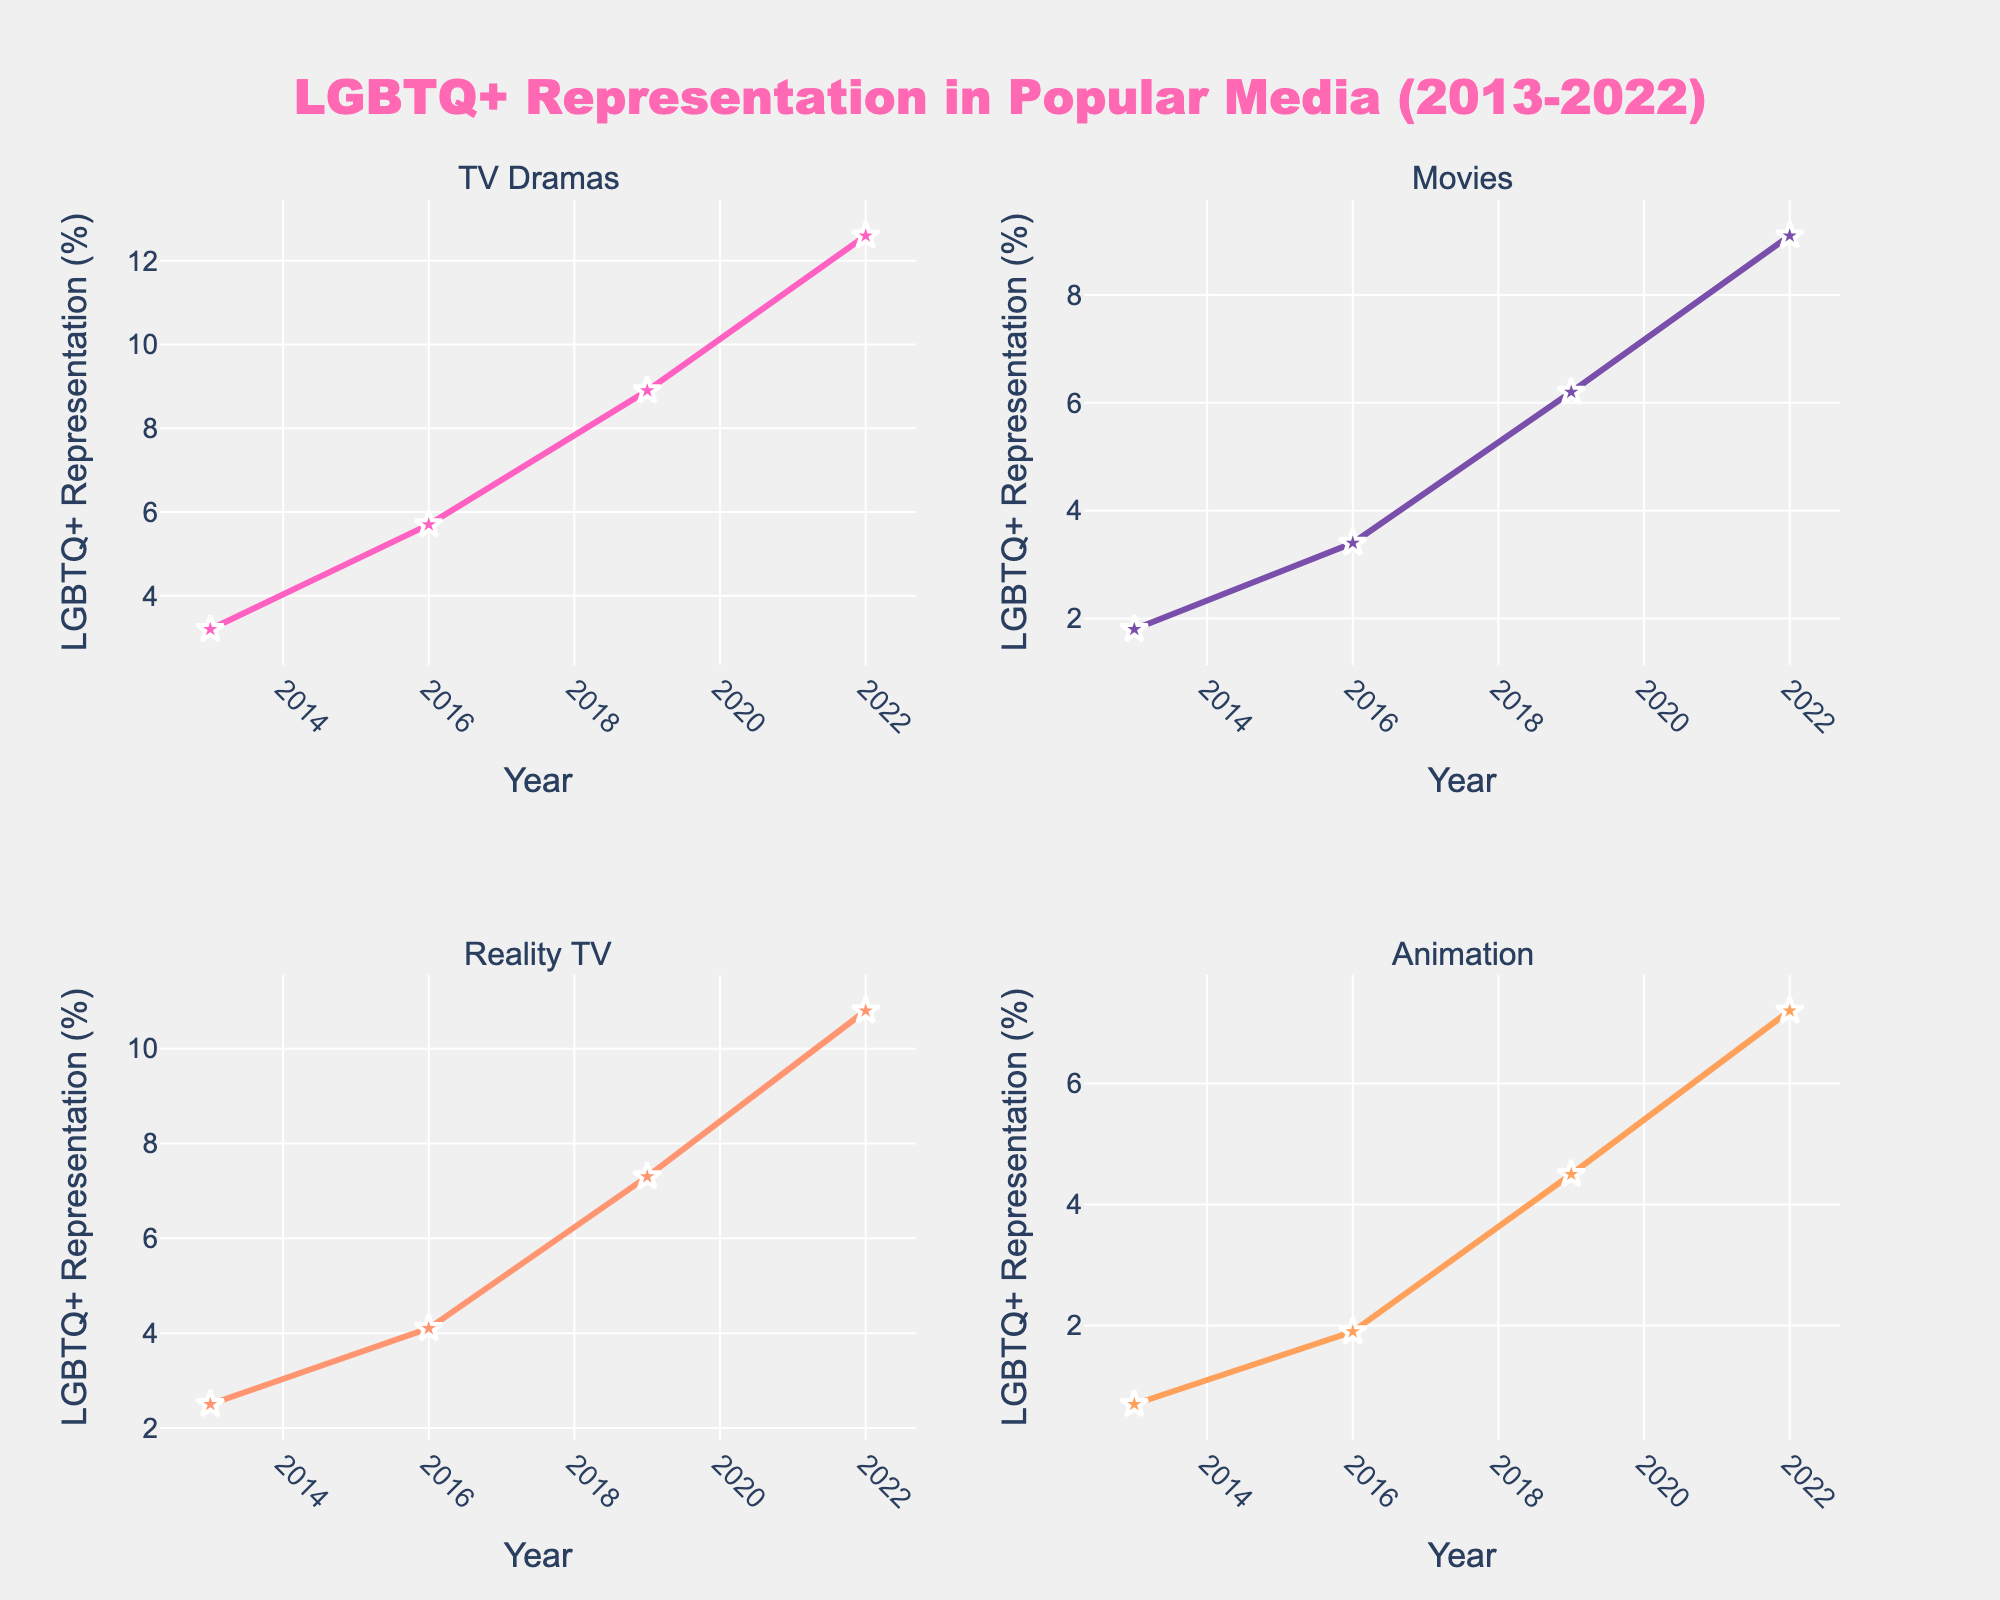What is the title of the figure? Observing the top-center part of the figure, the title clearly reads "LGBTQ+ Representation in Popular Media (2013-2022)".
Answer: LGBTQ+ Representation in Popular Media (2013-2022) Which genre shows the highest percentage of LGBTQ+ representation in 2022? By inspecting each subplot for the year 2022, it's noticeable that TV Dramas have the highest percentage of LGBTQ+ representation at 12.6%.
Answer: TV Dramas How does LGBTQ+ representation in TV Dramas change from the year 2013 to 2022? In the subplot for TV Dramas, the representation increases from 3.2% in 2013 to 12.6% in 2022. The difference can be calculated as 12.6% - 3.2% = 9.4%.
Answer: It increases by 9.4% Which genre shows the least increase in LGBTQ+ representation from 2013 to 2022? Comparing the differences for each genre, Animation goes from 0.7% in 2013 to 7.2% in 2022, which is an increase of 6.5%. This is the smallest increase among all genres.
Answer: Animation In which year does Reality TV surpass Movies in terms of LGBTQ+ representation, based on the graphed data? Looking at the subplots for Reality TV and Movies, Reality TV surpasses Movies in 2016 with 4.1% compared to Movies' 3.4%. This trend continues in subsequent years.
Answer: 2016 What is the average LGBTQ+ representation in Movies over the provided years? The values for Movies in the years 2013, 2016, 2019, and 2022 are 1.8%, 3.4%, 6.2%, and 9.1% respectively. The average is calculated as (1.8 + 3.4 + 6.2 + 9.1) / 4 = 5.125%.
Answer: 5.125% Which genre had the steepest increase in LGBTQ+ representation between 2016 and 2019? By evaluating the percentage increases in LGBTQ+ representation for each genre between 2016 and 2019: TV Dramas increased by 3.2%, Movies by 2.8%, Reality TV by 3.2%, and Animation by 2.6%. Both TV Dramas and Reality TV show the steepest increases of 3.2%.
Answer: TV Dramas and Reality TV How many genres had less than 5% representation in 2013? Checking each subplot for the year 2013, Movies (1.8%), Reality TV (2.5%), and Animation (0.7%) had less than 5% representation, totaling to 3 genres.
Answer: Three What years are displayed on the x-axes of the subplots? Each subplot's x-axis shows the years 2013, 2016, 2019, and 2022. This can be confirmed by looking at the bottom of any subplot.
Answer: 2013, 2016, 2019, 2022 